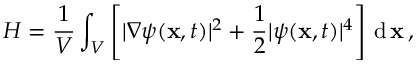<formula> <loc_0><loc_0><loc_500><loc_500>H = \frac { 1 } { V } \int _ { V } \left [ | \nabla \psi ( x , t ) | ^ { 2 } + \frac { 1 } { 2 } | \psi ( x , t ) | ^ { 4 } \right ] \, d \, x \, ,</formula> 